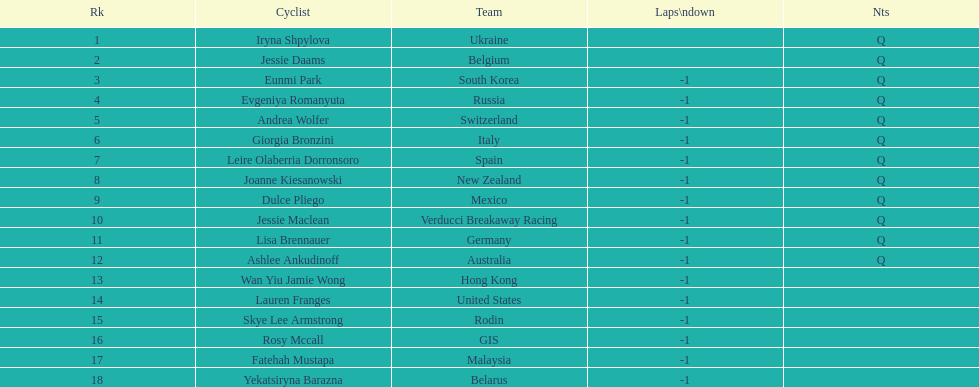Who was the first competitor to finish the race a lap behind? Eunmi Park. 